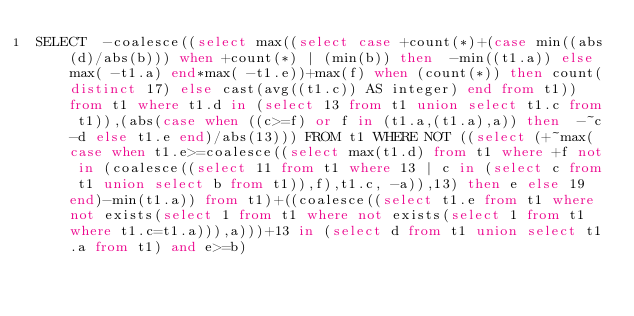Convert code to text. <code><loc_0><loc_0><loc_500><loc_500><_SQL_>SELECT  -coalesce((select max((select case +count(*)+(case min((abs(d)/abs(b))) when +count(*) | (min(b)) then  -min((t1.a)) else max( -t1.a) end*max( -t1.e))+max(f) when (count(*)) then count(distinct 17) else cast(avg((t1.c)) AS integer) end from t1)) from t1 where t1.d in (select 13 from t1 union select t1.c from t1)),(abs(case when ((c>=f) or f in (t1.a,(t1.a),a)) then  -~c-d else t1.e end)/abs(13))) FROM t1 WHERE NOT ((select (+~max(case when t1.e>=coalesce((select max(t1.d) from t1 where +f not in (coalesce((select 11 from t1 where 13 | c in (select c from t1 union select b from t1)),f),t1.c, -a)),13) then e else 19 end)-min(t1.a)) from t1)+((coalesce((select t1.e from t1 where not exists(select 1 from t1 where not exists(select 1 from t1 where t1.c=t1.a))),a)))+13 in (select d from t1 union select t1.a from t1) and e>=b)</code> 